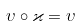<formula> <loc_0><loc_0><loc_500><loc_500>\upsilon \circ \varkappa = \upsilon</formula> 